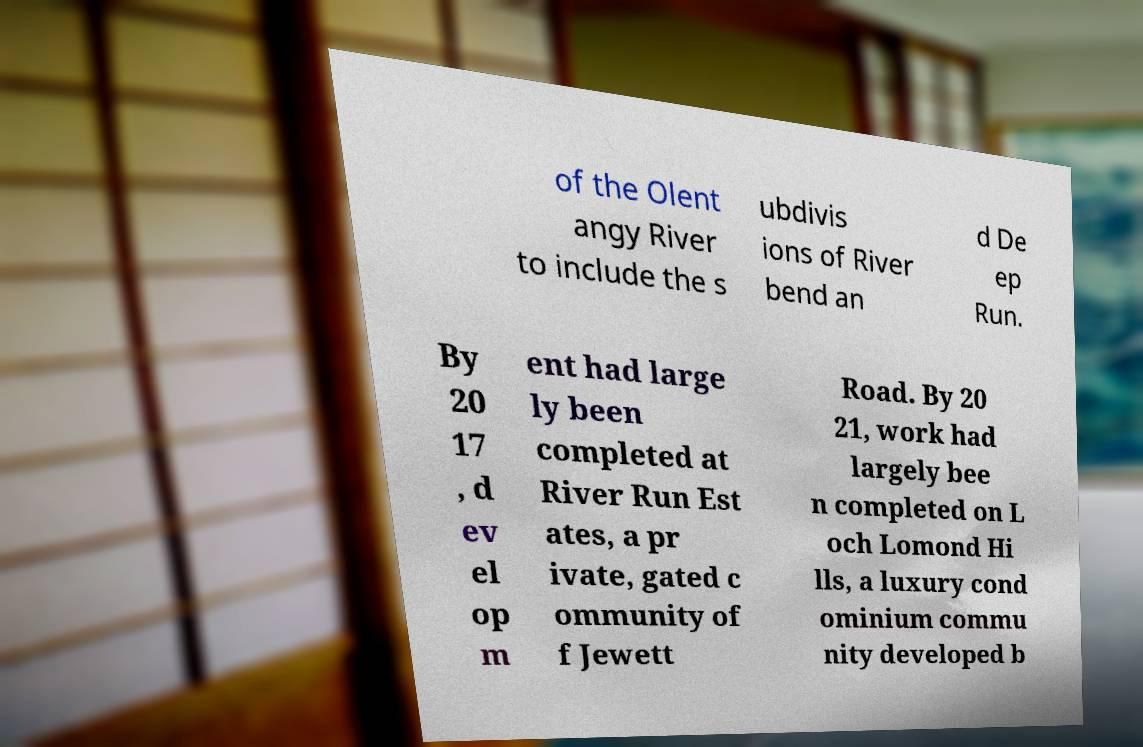There's text embedded in this image that I need extracted. Can you transcribe it verbatim? of the Olent angy River to include the s ubdivis ions of River bend an d De ep Run. By 20 17 , d ev el op m ent had large ly been completed at River Run Est ates, a pr ivate, gated c ommunity of f Jewett Road. By 20 21, work had largely bee n completed on L och Lomond Hi lls, a luxury cond ominium commu nity developed b 